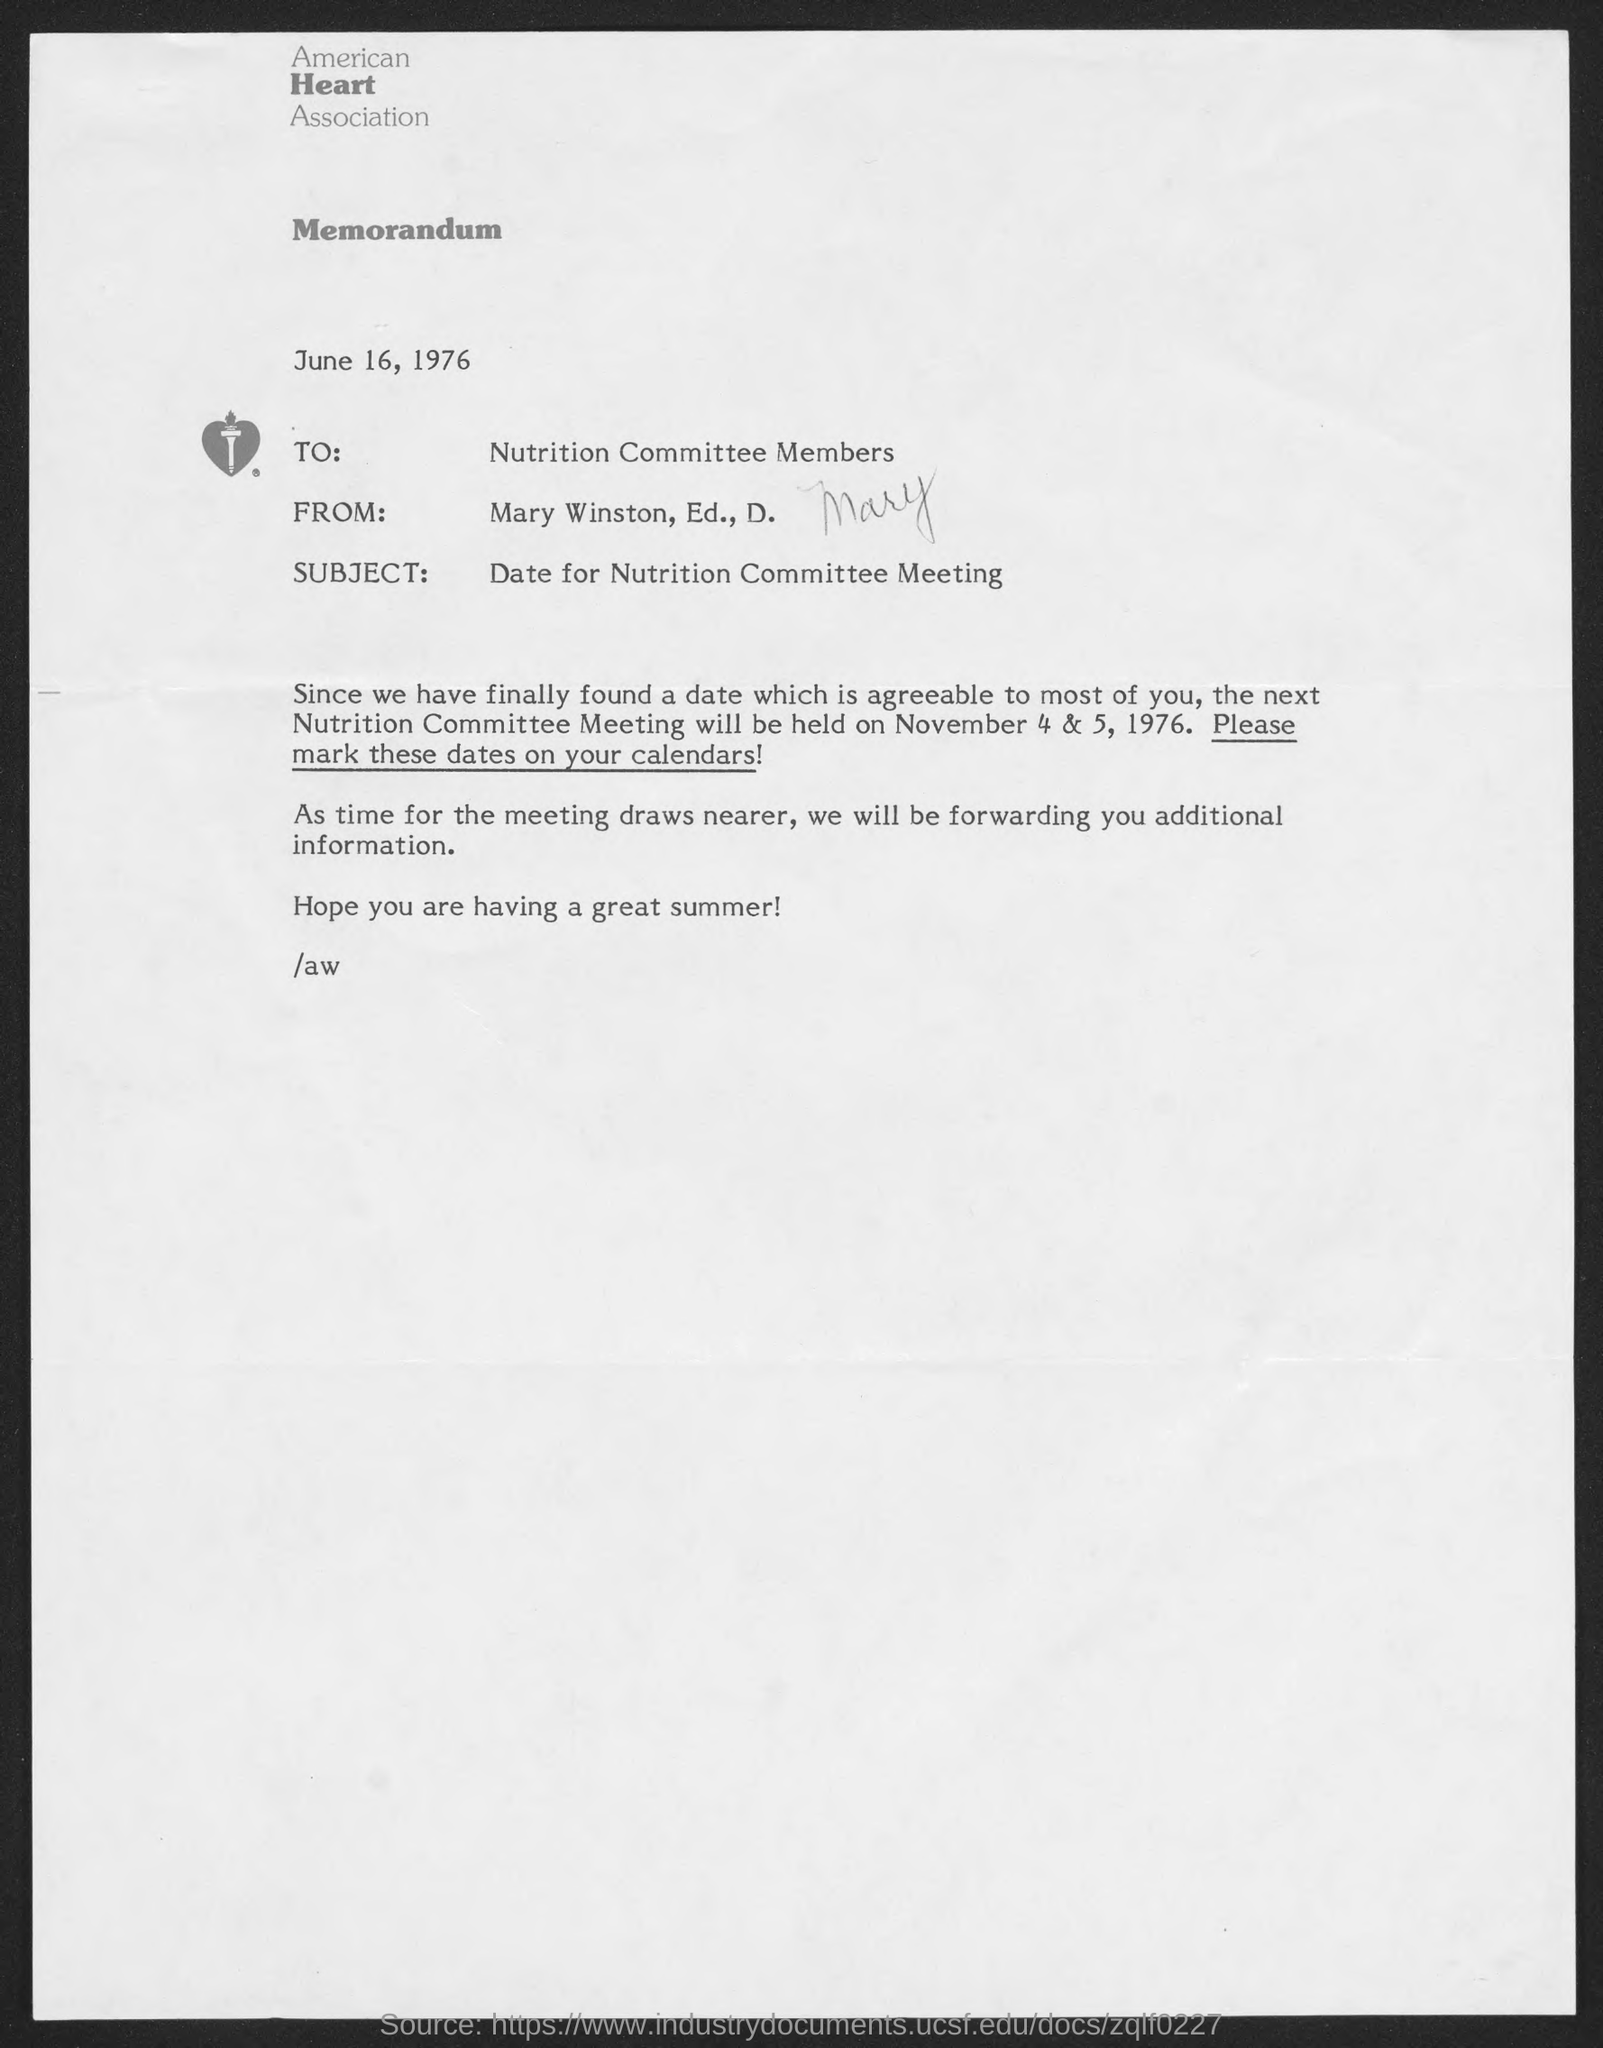Point out several critical features in this image. The American Heart Association is the name of the heart association located at the top of the page. The subject of the memorandum is the date for the Nutrition committee meeting. The Nutrition committee will hold its next meeting on November 4 & 5, 1976. The memorandum was dated June 16, 1976. 